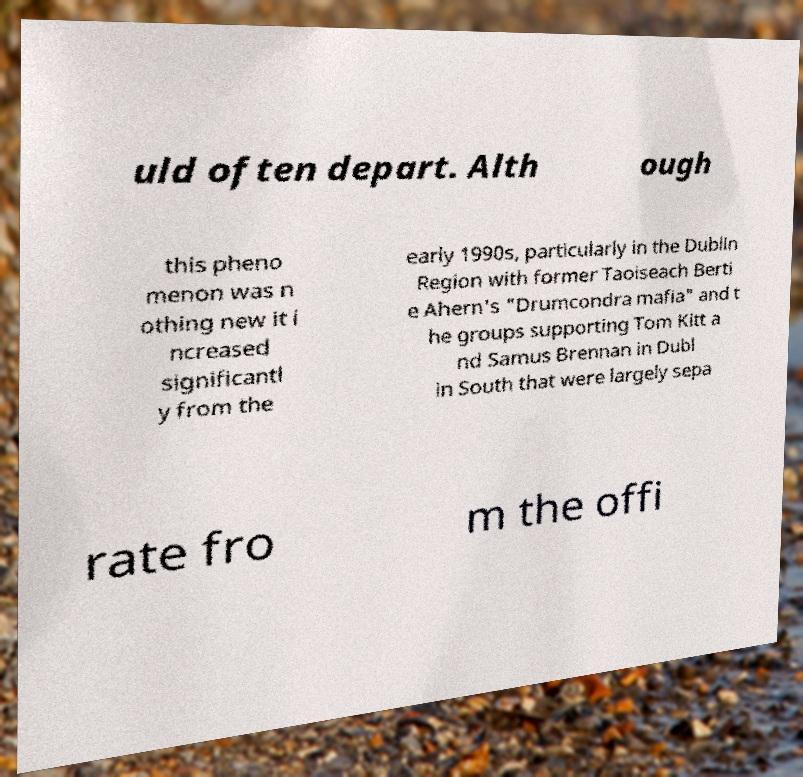What messages or text are displayed in this image? I need them in a readable, typed format. uld often depart. Alth ough this pheno menon was n othing new it i ncreased significantl y from the early 1990s, particularly in the Dublin Region with former Taoiseach Berti e Ahern's "Drumcondra mafia" and t he groups supporting Tom Kitt a nd Samus Brennan in Dubl in South that were largely sepa rate fro m the offi 